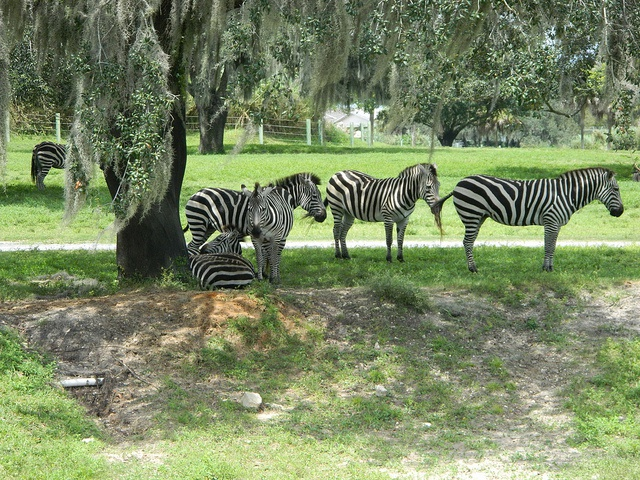Describe the objects in this image and their specific colors. I can see zebra in gray, black, darkgray, and olive tones, zebra in gray, black, darkgray, and ivory tones, zebra in gray, black, darkgray, and darkgreen tones, zebra in gray, black, darkgray, and lightgray tones, and zebra in gray, black, darkgray, and darkgreen tones in this image. 